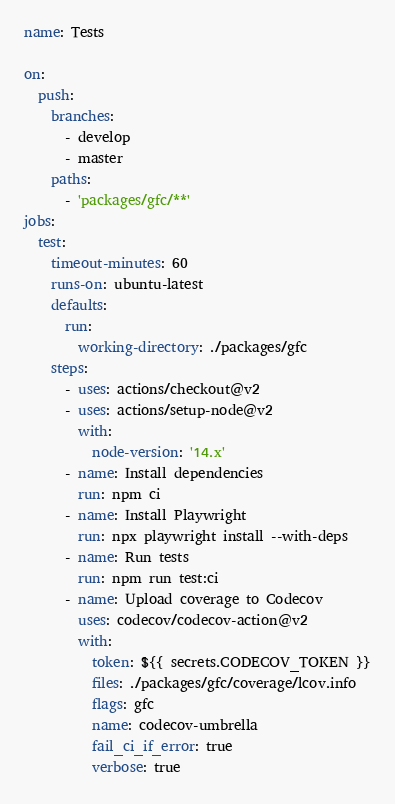<code> <loc_0><loc_0><loc_500><loc_500><_YAML_>name: Tests

on:
  push:
    branches:
      - develop
      - master
    paths:
      - 'packages/gfc/**'
jobs:
  test:
    timeout-minutes: 60
    runs-on: ubuntu-latest
    defaults:
      run:
        working-directory: ./packages/gfc
    steps:
      - uses: actions/checkout@v2
      - uses: actions/setup-node@v2
        with:
          node-version: '14.x'
      - name: Install dependencies
        run: npm ci
      - name: Install Playwright
        run: npx playwright install --with-deps
      - name: Run tests
        run: npm run test:ci
      - name: Upload coverage to Codecov
        uses: codecov/codecov-action@v2
        with:
          token: ${{ secrets.CODECOV_TOKEN }}
          files: ./packages/gfc/coverage/lcov.info
          flags: gfc
          name: codecov-umbrella
          fail_ci_if_error: true
          verbose: true</code> 